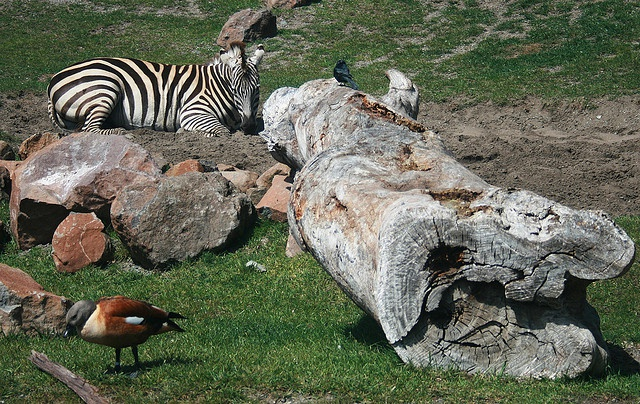Describe the objects in this image and their specific colors. I can see zebra in gray, black, ivory, and darkgray tones, bird in gray, black, maroon, and darkgreen tones, and bird in gray, black, blue, and darkblue tones in this image. 